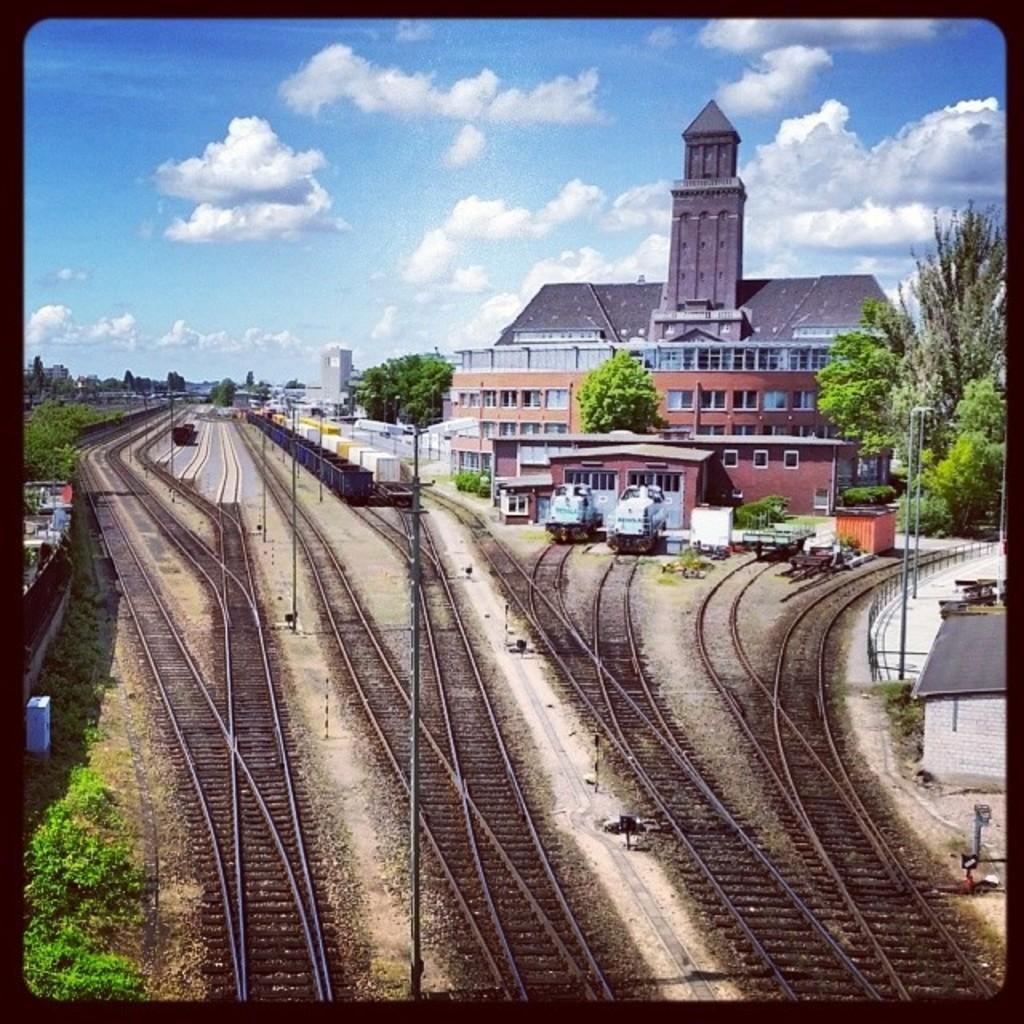How would you summarize this image in a sentence or two? In this image we can see railway tracks on the ground and on the left side there are plants, trees and grass on the ground and we can see the wall. In the background there are buildings, windows, roof, truss, poles, trains on the railway tracks and clouds in the sky. 